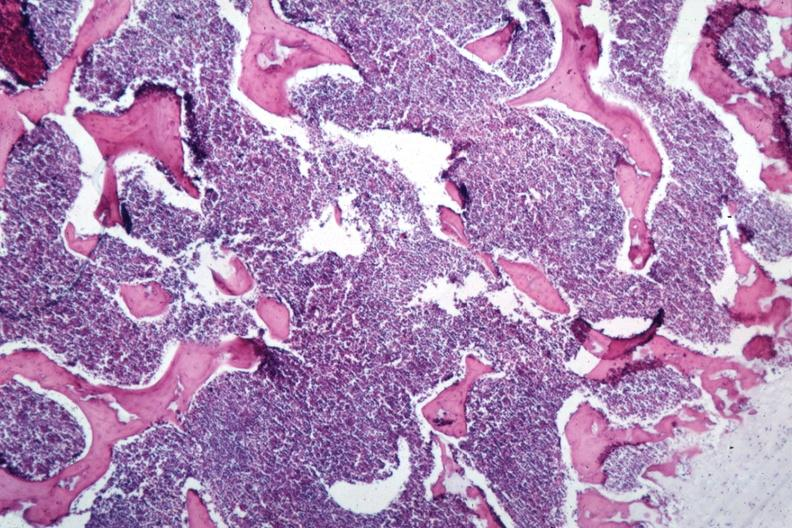does choanal patency show sheets of lymphoma cells?
Answer the question using a single word or phrase. No 